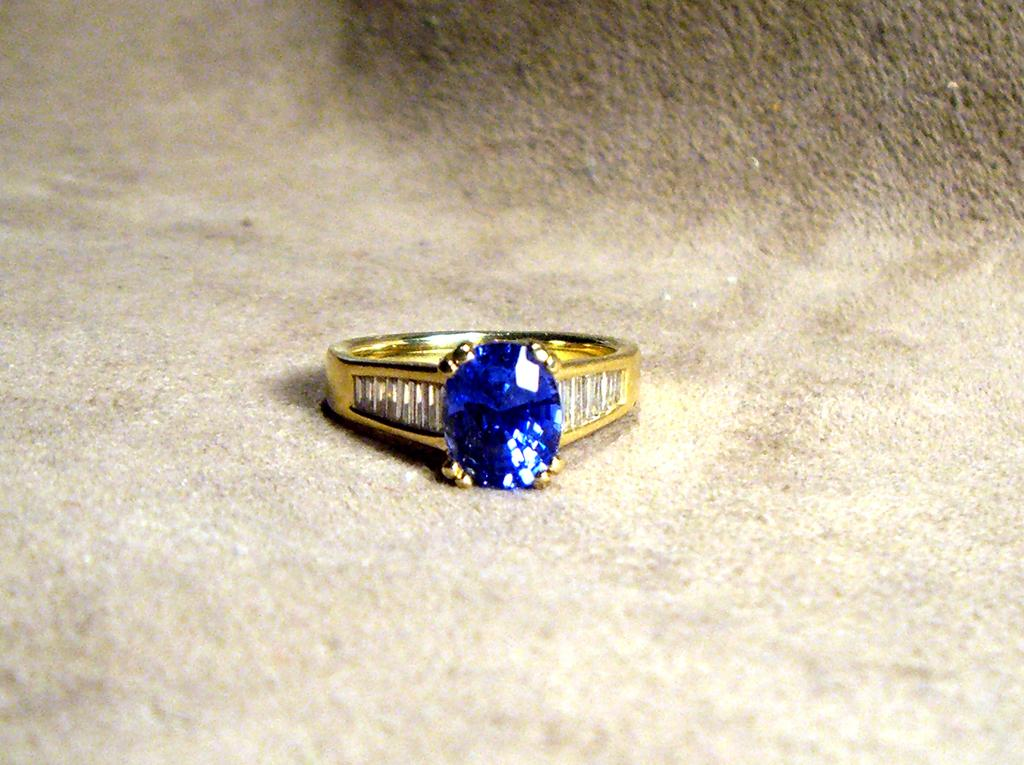What type of jewelry is present in the image? There is a gold ring in the image. What is the color of the stone on the gold ring? The gold ring has a blue stone. Where is the gold ring placed in the image? The gold ring is kept on the ground. What does the son of the person who owns the gold ring look like? There is no information about the owner of the gold ring or their son in the image, so we cannot answer this question. 